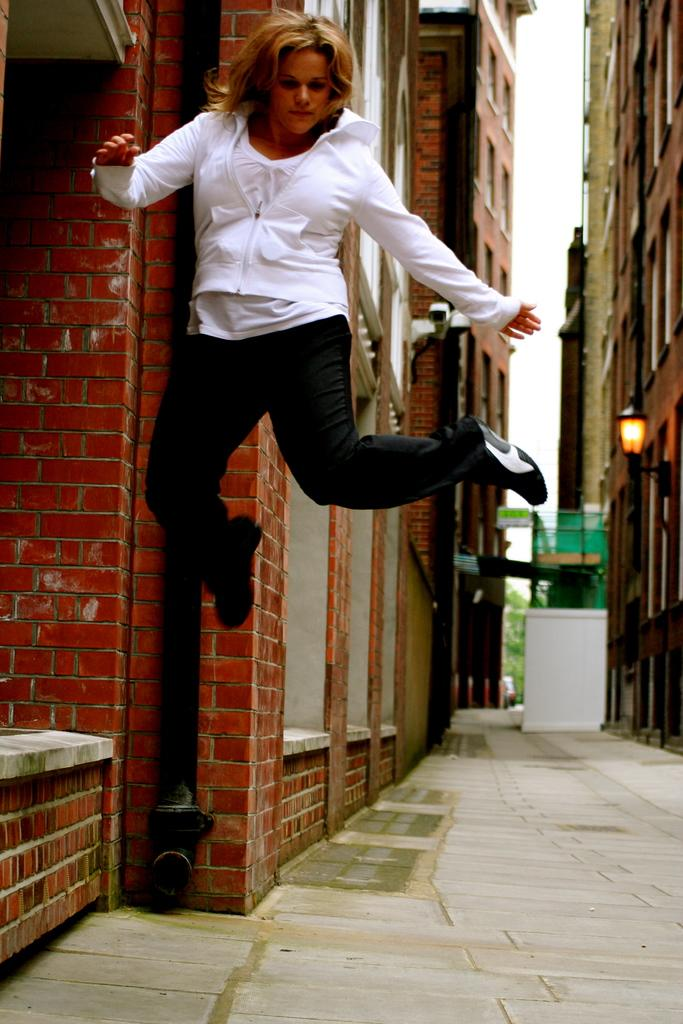What is the woman doing in the image? The woman is in the air in the image. What is located at the bottom of the image? There is a walkway at the bottom of the image. What can be seen in the background of the image? There are buildings, a brick wall, a street light, a tree, and other objects in the background of the image. What part of the natural environment is visible in the image? The sky is visible in the background of the image. What type of whip can be seen in the woman's hand in the image? There is no whip present in the image. What time of day is it in the image, considering the presence of the afternoon sun? The image does not provide any information about the time of day, and there is no mention of the sun in the facts provided. 